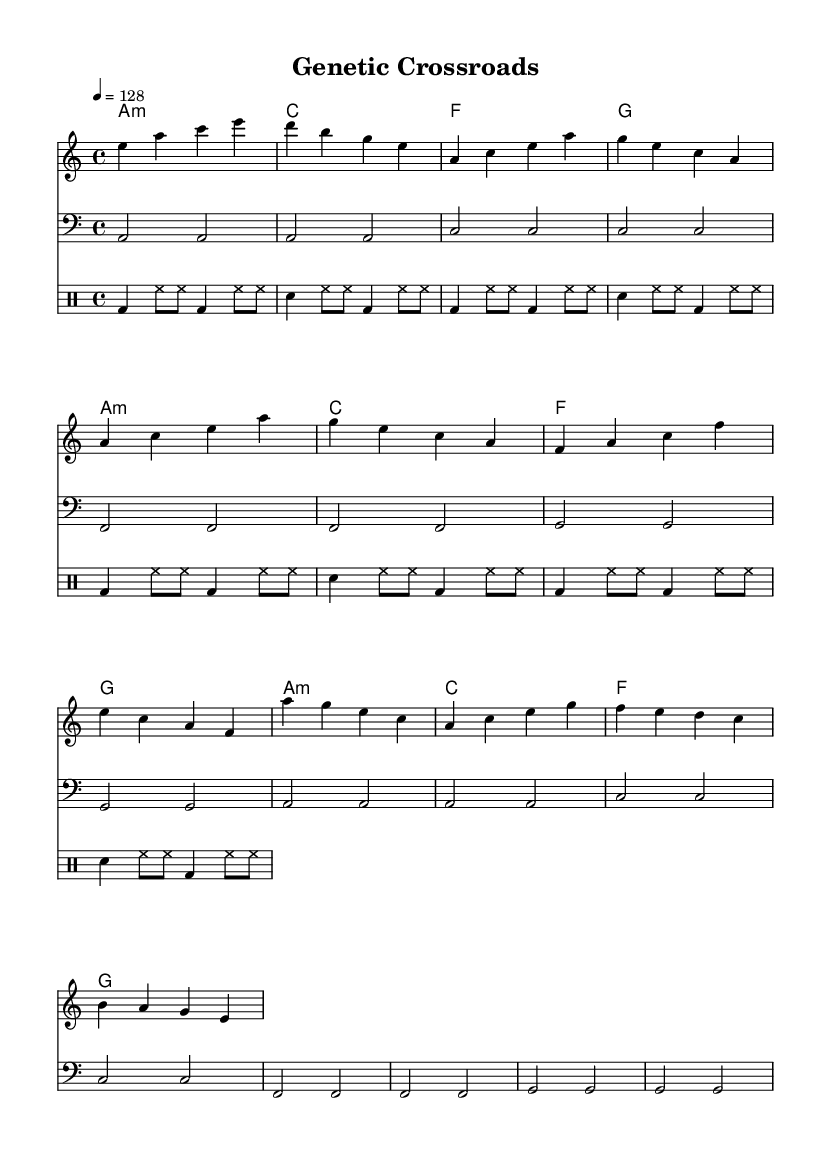What is the key signature of this music? The key signature is indicated at the beginning of the staff, which shows an "A minor" key. A minor has no sharps or flats, confirming that this is the key signature.
Answer: A minor What is the time signature of this music? The time signature is visible at the beginning of the score, marked as "4/4". This means there are four beats in each measure and a quarter note receives one beat.
Answer: 4/4 What is the tempo marking of this music? The tempo marking shown in the score is "4 = 128", indicating that there are 128 beats per minute. This is a common tempo for dance music, suggesting a lively pace.
Answer: 128 How many measures are in the chorus section? By examining the notation in the melody, we can identify that the chorus spans four measures. The spacing and structure indicate that it contains distinct musical phrases.
Answer: 4 What type of chord is played in the first measure? In the first measure of the harmonies, the chord is labeled as "A minor", which is a triad consisting of A, C, and E notes, indicating its minor quality.
Answer: A minor What lyrical theme is presented in the song? The lyrics reflect on ethical dilemmas and advancements in biotechnology, suggesting a philosophical consideration of the consequences of genetic manipulation. This theme is prevalent throughout the text.
Answer: Ethical dilemmas What is the primary drum patterning style used? The drum patterns are constructed with a repetitive framework consisting of bass drums and hi-hats, typical in house music, creating a driving rhythmic force crucial for dance genres.
Answer: House music 